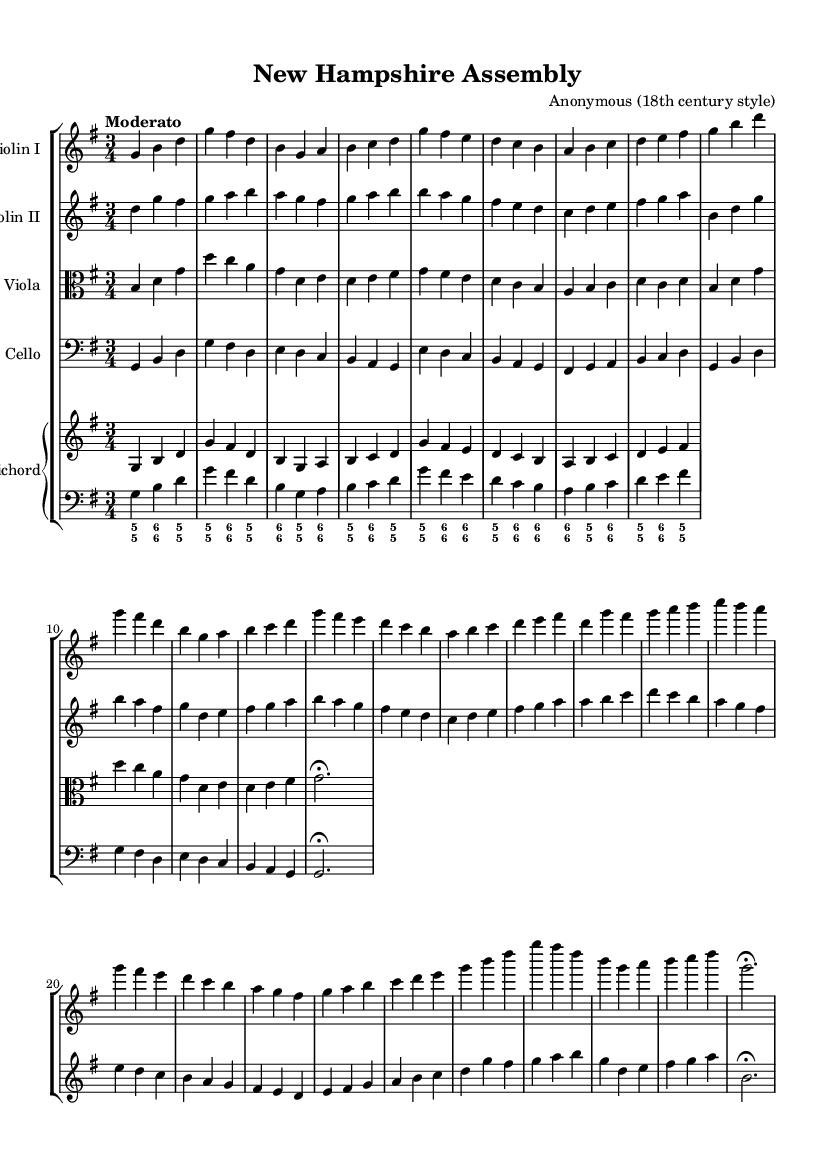What is the key signature of this music? The key signature is shown at the beginning of the staff and indicates G major, which has one sharp (F-sharp).
Answer: G major What is the time signature of this music? The time signature is displayed at the start of the score, showing three beats per measure, which is notated as 3/4.
Answer: 3/4 What is the tempo marking of this piece? The tempo marking is placed at the top of the score, indicating a "Moderato" tempo, which suggests a moderate speed.
Answer: Moderato How many parts are there in the ensemble? The music score shows different staves for each instrument, indicating there are four distinct parts (two violins, viola, and cello) plus a keyboard part.
Answer: Four What musical form does this piece follow? By examining the thematic repetitions and variations displayed in the sheet music, it can be inferred that the piece exhibits a structure common in Baroque chamber music, typically consisting of themes and variations that eventually return to the original themes.
Answer: Theme and variations Which instruments are included in this chamber music piece? The score explicitly lists the parts and instrument names, which include two violins, a viola, a cello, and a harpsichord.
Answer: Two violins, viola, cello, harpsichord What type of ornamentation might be expected in this piece, given its style? In Baroque music, common ornamentation includes trills, mordents, and appoggiaturas, although the specific sheet music does not illustrate these; they could be applied in performance contexts as stylistic interpretation.
Answer: Trills, mordents, appoggiaturas 